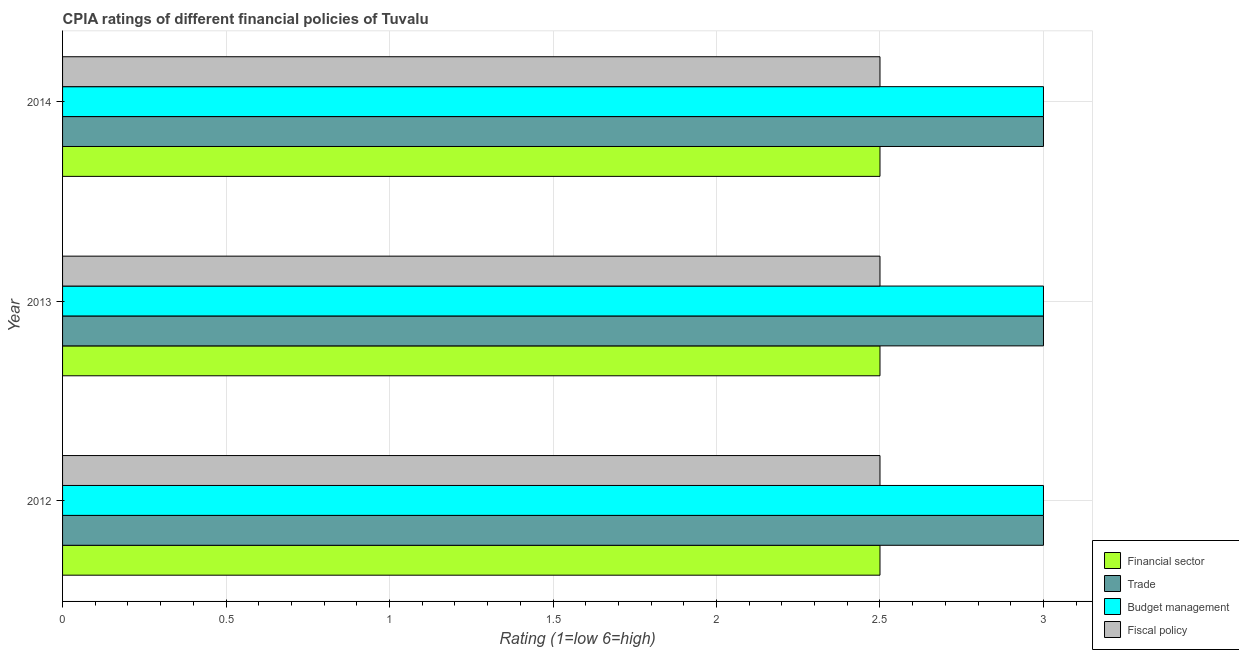How many different coloured bars are there?
Give a very brief answer. 4. How many bars are there on the 3rd tick from the top?
Provide a short and direct response. 4. What is the label of the 3rd group of bars from the top?
Offer a terse response. 2012. What is the cpia rating of fiscal policy in 2012?
Offer a terse response. 2.5. Across all years, what is the maximum cpia rating of financial sector?
Provide a succinct answer. 2.5. Across all years, what is the minimum cpia rating of trade?
Keep it short and to the point. 3. In which year was the cpia rating of budget management maximum?
Your response must be concise. 2012. What is the total cpia rating of budget management in the graph?
Give a very brief answer. 9. What is the average cpia rating of financial sector per year?
Provide a short and direct response. 2.5. What is the ratio of the cpia rating of financial sector in 2012 to that in 2013?
Provide a succinct answer. 1. Is the cpia rating of fiscal policy in 2012 less than that in 2014?
Provide a succinct answer. No. What is the difference between the highest and the second highest cpia rating of fiscal policy?
Give a very brief answer. 0. What is the difference between the highest and the lowest cpia rating of fiscal policy?
Offer a terse response. 0. What does the 3rd bar from the top in 2013 represents?
Provide a short and direct response. Trade. What does the 3rd bar from the bottom in 2012 represents?
Your response must be concise. Budget management. Is it the case that in every year, the sum of the cpia rating of financial sector and cpia rating of trade is greater than the cpia rating of budget management?
Offer a terse response. Yes. Are all the bars in the graph horizontal?
Provide a short and direct response. Yes. Are the values on the major ticks of X-axis written in scientific E-notation?
Make the answer very short. No. Where does the legend appear in the graph?
Your answer should be compact. Bottom right. How many legend labels are there?
Provide a short and direct response. 4. How are the legend labels stacked?
Keep it short and to the point. Vertical. What is the title of the graph?
Ensure brevity in your answer.  CPIA ratings of different financial policies of Tuvalu. Does "PFC gas" appear as one of the legend labels in the graph?
Give a very brief answer. No. What is the Rating (1=low 6=high) of Budget management in 2012?
Your response must be concise. 3. What is the Rating (1=low 6=high) of Fiscal policy in 2012?
Keep it short and to the point. 2.5. What is the Rating (1=low 6=high) of Financial sector in 2013?
Keep it short and to the point. 2.5. What is the Rating (1=low 6=high) in Financial sector in 2014?
Keep it short and to the point. 2.5. Across all years, what is the maximum Rating (1=low 6=high) of Trade?
Your answer should be very brief. 3. Across all years, what is the maximum Rating (1=low 6=high) in Budget management?
Provide a short and direct response. 3. Across all years, what is the maximum Rating (1=low 6=high) of Fiscal policy?
Provide a short and direct response. 2.5. Across all years, what is the minimum Rating (1=low 6=high) in Financial sector?
Provide a short and direct response. 2.5. Across all years, what is the minimum Rating (1=low 6=high) of Fiscal policy?
Offer a very short reply. 2.5. What is the total Rating (1=low 6=high) in Budget management in the graph?
Provide a succinct answer. 9. What is the difference between the Rating (1=low 6=high) of Financial sector in 2012 and that in 2013?
Give a very brief answer. 0. What is the difference between the Rating (1=low 6=high) of Trade in 2012 and that in 2013?
Provide a succinct answer. 0. What is the difference between the Rating (1=low 6=high) in Budget management in 2012 and that in 2013?
Offer a terse response. 0. What is the difference between the Rating (1=low 6=high) of Fiscal policy in 2012 and that in 2013?
Provide a succinct answer. 0. What is the difference between the Rating (1=low 6=high) in Trade in 2013 and that in 2014?
Provide a succinct answer. 0. What is the difference between the Rating (1=low 6=high) of Budget management in 2013 and that in 2014?
Offer a terse response. 0. What is the difference between the Rating (1=low 6=high) in Financial sector in 2012 and the Rating (1=low 6=high) in Fiscal policy in 2013?
Make the answer very short. 0. What is the difference between the Rating (1=low 6=high) of Trade in 2012 and the Rating (1=low 6=high) of Budget management in 2013?
Provide a short and direct response. 0. What is the difference between the Rating (1=low 6=high) of Trade in 2012 and the Rating (1=low 6=high) of Fiscal policy in 2013?
Give a very brief answer. 0.5. What is the difference between the Rating (1=low 6=high) in Financial sector in 2012 and the Rating (1=low 6=high) in Fiscal policy in 2014?
Give a very brief answer. 0. What is the difference between the Rating (1=low 6=high) in Trade in 2012 and the Rating (1=low 6=high) in Budget management in 2014?
Offer a very short reply. 0. What is the difference between the Rating (1=low 6=high) of Trade in 2012 and the Rating (1=low 6=high) of Fiscal policy in 2014?
Your answer should be compact. 0.5. What is the difference between the Rating (1=low 6=high) in Budget management in 2012 and the Rating (1=low 6=high) in Fiscal policy in 2014?
Offer a terse response. 0.5. What is the difference between the Rating (1=low 6=high) in Financial sector in 2013 and the Rating (1=low 6=high) in Fiscal policy in 2014?
Give a very brief answer. 0. What is the difference between the Rating (1=low 6=high) of Trade in 2013 and the Rating (1=low 6=high) of Fiscal policy in 2014?
Make the answer very short. 0.5. In the year 2012, what is the difference between the Rating (1=low 6=high) in Trade and Rating (1=low 6=high) in Fiscal policy?
Make the answer very short. 0.5. In the year 2013, what is the difference between the Rating (1=low 6=high) in Financial sector and Rating (1=low 6=high) in Trade?
Your response must be concise. -0.5. In the year 2013, what is the difference between the Rating (1=low 6=high) in Financial sector and Rating (1=low 6=high) in Budget management?
Offer a very short reply. -0.5. In the year 2014, what is the difference between the Rating (1=low 6=high) of Financial sector and Rating (1=low 6=high) of Fiscal policy?
Make the answer very short. 0. In the year 2014, what is the difference between the Rating (1=low 6=high) of Trade and Rating (1=low 6=high) of Budget management?
Offer a very short reply. 0. What is the ratio of the Rating (1=low 6=high) in Financial sector in 2012 to that in 2013?
Keep it short and to the point. 1. What is the ratio of the Rating (1=low 6=high) of Fiscal policy in 2012 to that in 2013?
Make the answer very short. 1. What is the ratio of the Rating (1=low 6=high) of Trade in 2012 to that in 2014?
Offer a terse response. 1. What is the ratio of the Rating (1=low 6=high) in Fiscal policy in 2012 to that in 2014?
Offer a very short reply. 1. What is the ratio of the Rating (1=low 6=high) in Trade in 2013 to that in 2014?
Offer a terse response. 1. What is the difference between the highest and the second highest Rating (1=low 6=high) of Trade?
Ensure brevity in your answer.  0. What is the difference between the highest and the second highest Rating (1=low 6=high) of Budget management?
Ensure brevity in your answer.  0. What is the difference between the highest and the lowest Rating (1=low 6=high) in Financial sector?
Provide a short and direct response. 0. What is the difference between the highest and the lowest Rating (1=low 6=high) of Trade?
Give a very brief answer. 0. What is the difference between the highest and the lowest Rating (1=low 6=high) of Budget management?
Your response must be concise. 0. What is the difference between the highest and the lowest Rating (1=low 6=high) in Fiscal policy?
Provide a short and direct response. 0. 